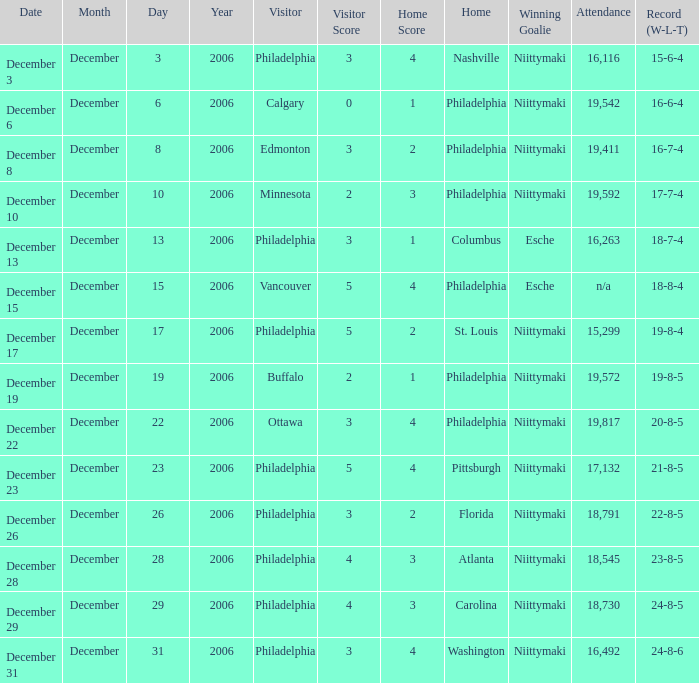What was the resolution when the number of attendees was 19,592? Niittymaki. 